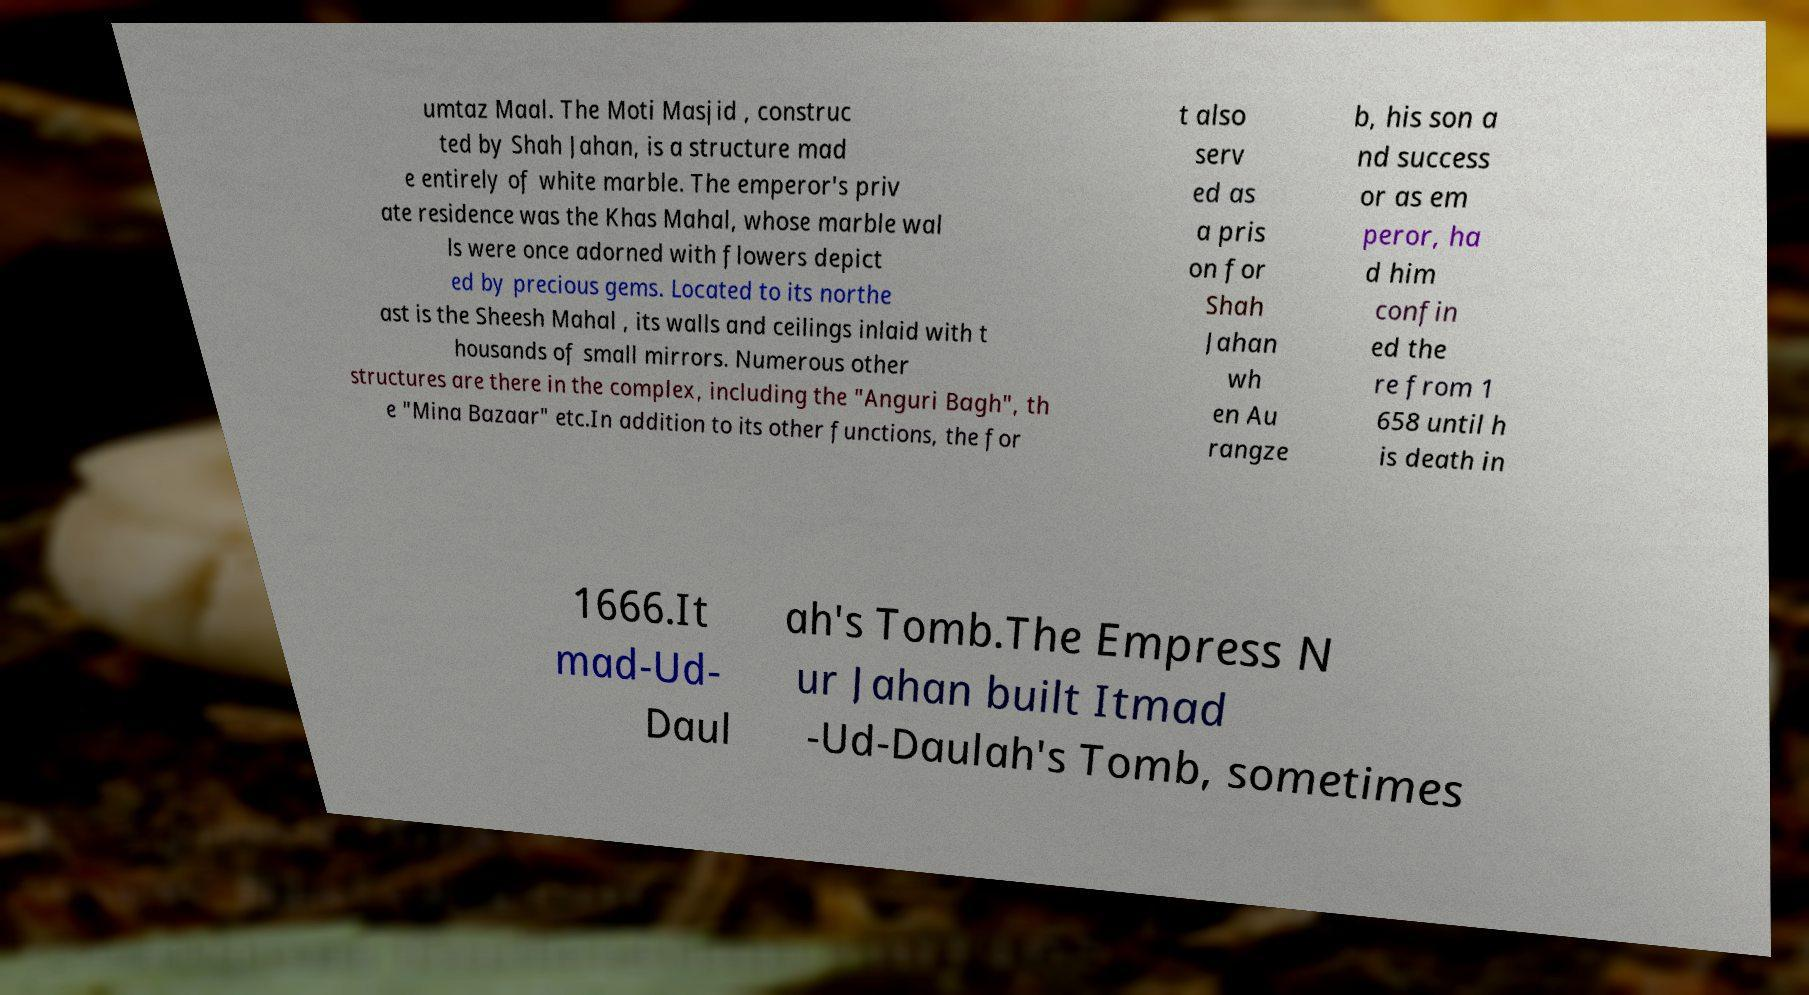Can you accurately transcribe the text from the provided image for me? umtaz Maal. The Moti Masjid , construc ted by Shah Jahan, is a structure mad e entirely of white marble. The emperor's priv ate residence was the Khas Mahal, whose marble wal ls were once adorned with flowers depict ed by precious gems. Located to its northe ast is the Sheesh Mahal , its walls and ceilings inlaid with t housands of small mirrors. Numerous other structures are there in the complex, including the "Anguri Bagh", th e "Mina Bazaar" etc.In addition to its other functions, the for t also serv ed as a pris on for Shah Jahan wh en Au rangze b, his son a nd success or as em peror, ha d him confin ed the re from 1 658 until h is death in 1666.It mad-Ud- Daul ah's Tomb.The Empress N ur Jahan built Itmad -Ud-Daulah's Tomb, sometimes 